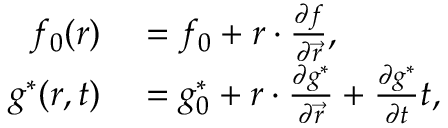<formula> <loc_0><loc_0><loc_500><loc_500>\begin{array} { r l } { f _ { 0 } ( r ) } & = f _ { 0 } + r \cdot \frac { \partial f } { \partial \vec { r } } , } \\ { g ^ { \ast } ( r , t ) } & = g _ { 0 } ^ { \ast } + r \cdot \frac { \partial g ^ { \ast } } { \partial \vec { r } } + \frac { \partial g ^ { \ast } } { \partial t } t , } \end{array}</formula> 